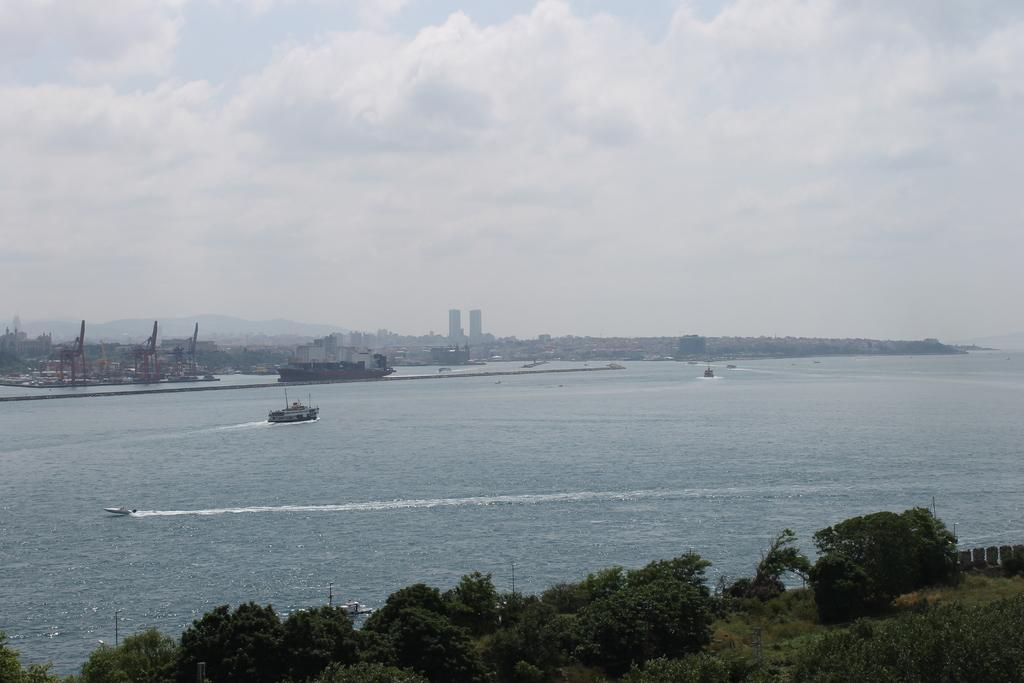What is floating on the water in the image? There are boats floating on the water in the image. What type of vegetation can be seen at the bottom of the image? There are trees at the bottom of the image. What part of the natural environment is visible in the background of the image? The sky is visible in the background of the image. What type of wax can be seen dripping from the trees in the image? There is no wax present in the image; it features boats floating on water and trees at the bottom. What advice is being given by the trees in the image? There is no advice being given by the trees in the image; they are simply depicted as part of the landscape. 